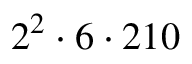<formula> <loc_0><loc_0><loc_500><loc_500>2 ^ { 2 } \cdot 6 \cdot 2 1 0</formula> 